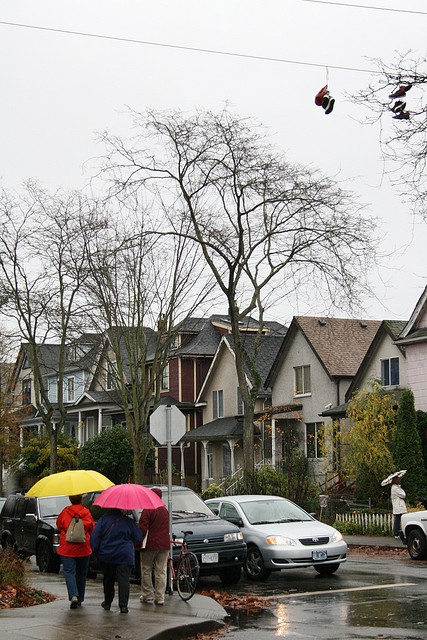Describe the objects in this image and their specific colors. I can see car in white, lightgray, black, darkgray, and gray tones, car in white, black, darkgray, gray, and lightgray tones, car in white, black, darkgray, gray, and maroon tones, people in white, black, gray, maroon, and darkgray tones, and people in white, black, navy, and gray tones in this image. 